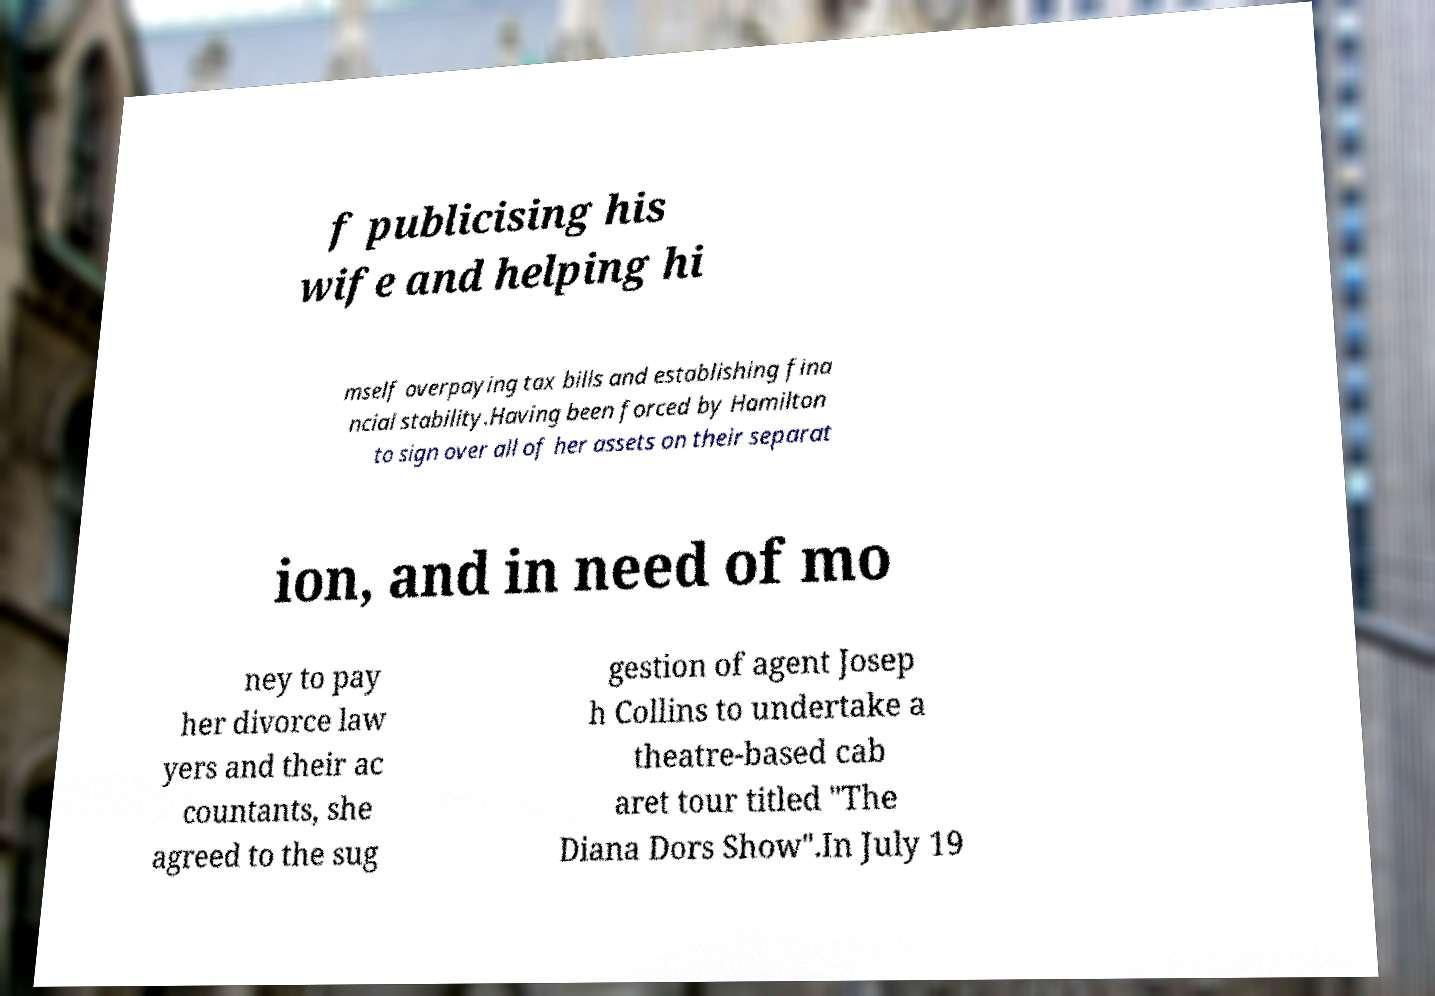Please identify and transcribe the text found in this image. f publicising his wife and helping hi mself overpaying tax bills and establishing fina ncial stability.Having been forced by Hamilton to sign over all of her assets on their separat ion, and in need of mo ney to pay her divorce law yers and their ac countants, she agreed to the sug gestion of agent Josep h Collins to undertake a theatre-based cab aret tour titled "The Diana Dors Show".In July 19 